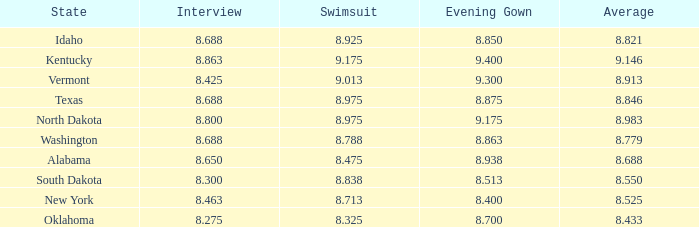Who had the lowest interview score from South Dakota with an evening gown less than 8.513? None. 